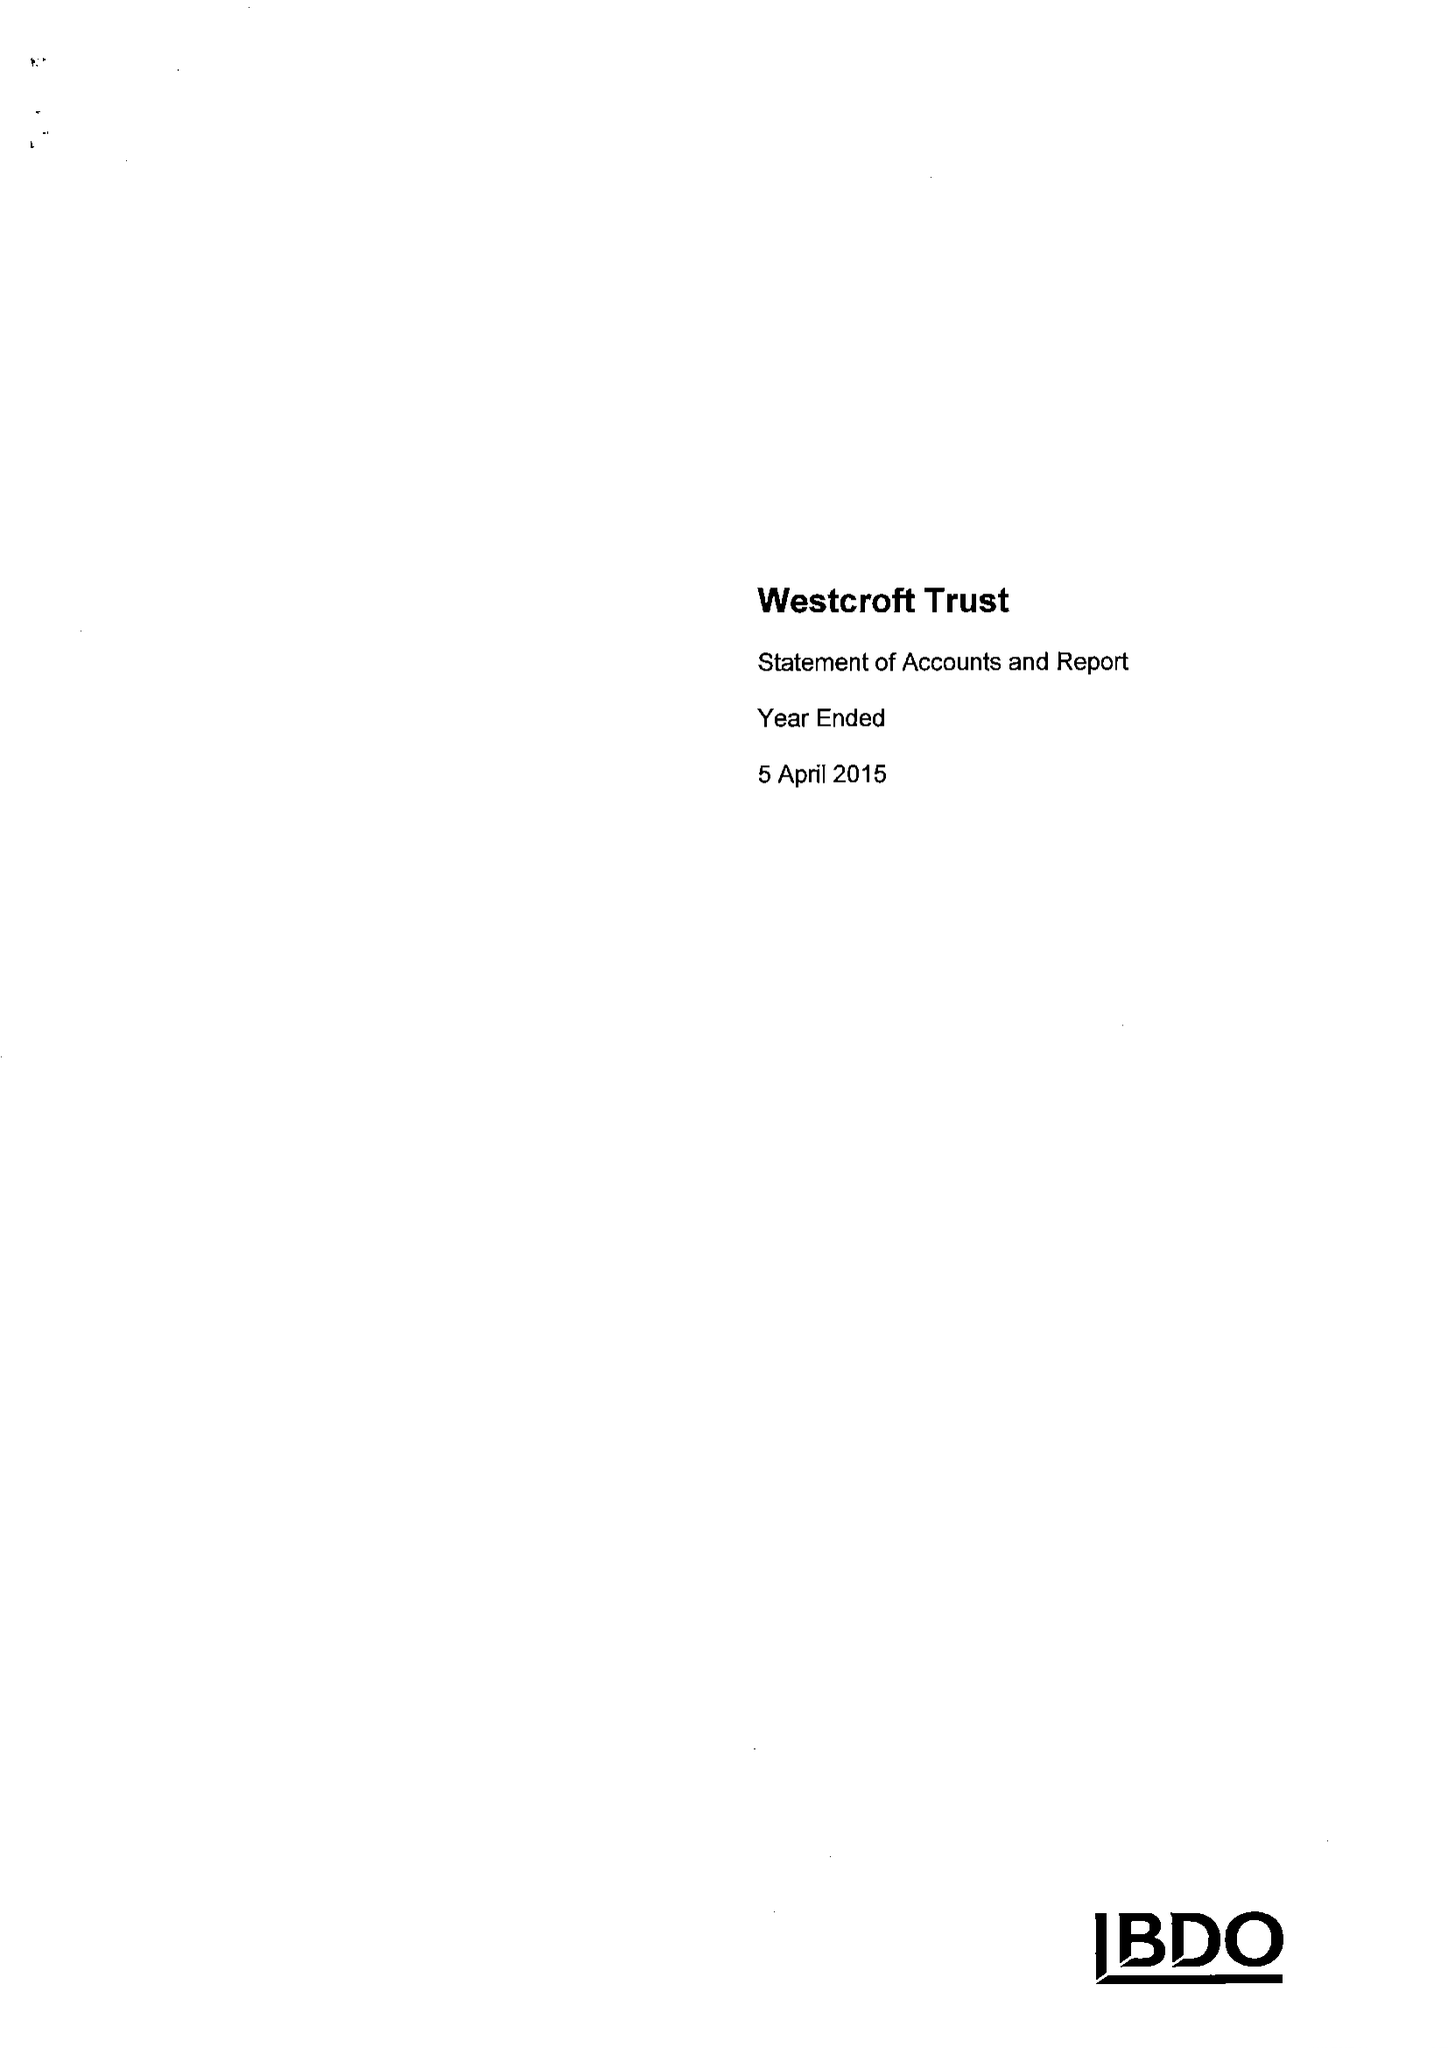What is the value for the address__street_line?
Answer the question using a single word or phrase. 32 HAMPTON ROAD 